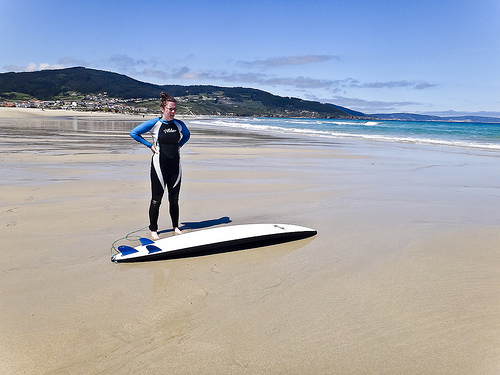What wildlife might be typical in this beach setting? This coastal area is likely home to marine birds such as gulls and possibly migratory shorebirds. The ocean might host dolphins, seals, and various fish species, attracting nature enthusiasts and wildlife observers. Are there any environmental concerns visible in this area? From what is visible, the beach appears clean and well-maintained, though concerns such as beach erosion, marine debris, and habitat disruption for local wildlife are common issues for coastal areas like this. 